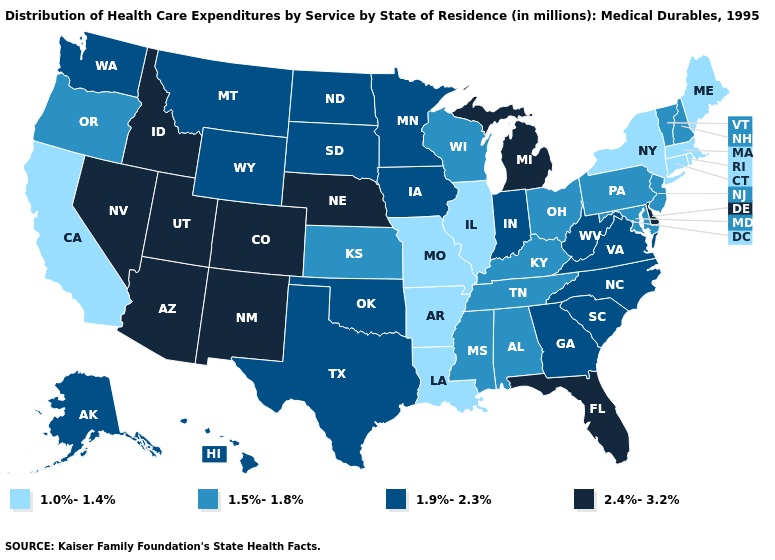What is the highest value in the Northeast ?
Answer briefly. 1.5%-1.8%. What is the value of Arkansas?
Give a very brief answer. 1.0%-1.4%. What is the value of Pennsylvania?
Quick response, please. 1.5%-1.8%. Does the map have missing data?
Keep it brief. No. Does Maine have a lower value than Connecticut?
Keep it brief. No. What is the value of Ohio?
Quick response, please. 1.5%-1.8%. What is the highest value in the MidWest ?
Write a very short answer. 2.4%-3.2%. Name the states that have a value in the range 1.9%-2.3%?
Be succinct. Alaska, Georgia, Hawaii, Indiana, Iowa, Minnesota, Montana, North Carolina, North Dakota, Oklahoma, South Carolina, South Dakota, Texas, Virginia, Washington, West Virginia, Wyoming. Name the states that have a value in the range 1.0%-1.4%?
Keep it brief. Arkansas, California, Connecticut, Illinois, Louisiana, Maine, Massachusetts, Missouri, New York, Rhode Island. Among the states that border Idaho , does Utah have the highest value?
Give a very brief answer. Yes. What is the value of Illinois?
Give a very brief answer. 1.0%-1.4%. What is the lowest value in the USA?
Keep it brief. 1.0%-1.4%. What is the lowest value in states that border Maryland?
Quick response, please. 1.5%-1.8%. Name the states that have a value in the range 1.5%-1.8%?
Quick response, please. Alabama, Kansas, Kentucky, Maryland, Mississippi, New Hampshire, New Jersey, Ohio, Oregon, Pennsylvania, Tennessee, Vermont, Wisconsin. How many symbols are there in the legend?
Concise answer only. 4. 